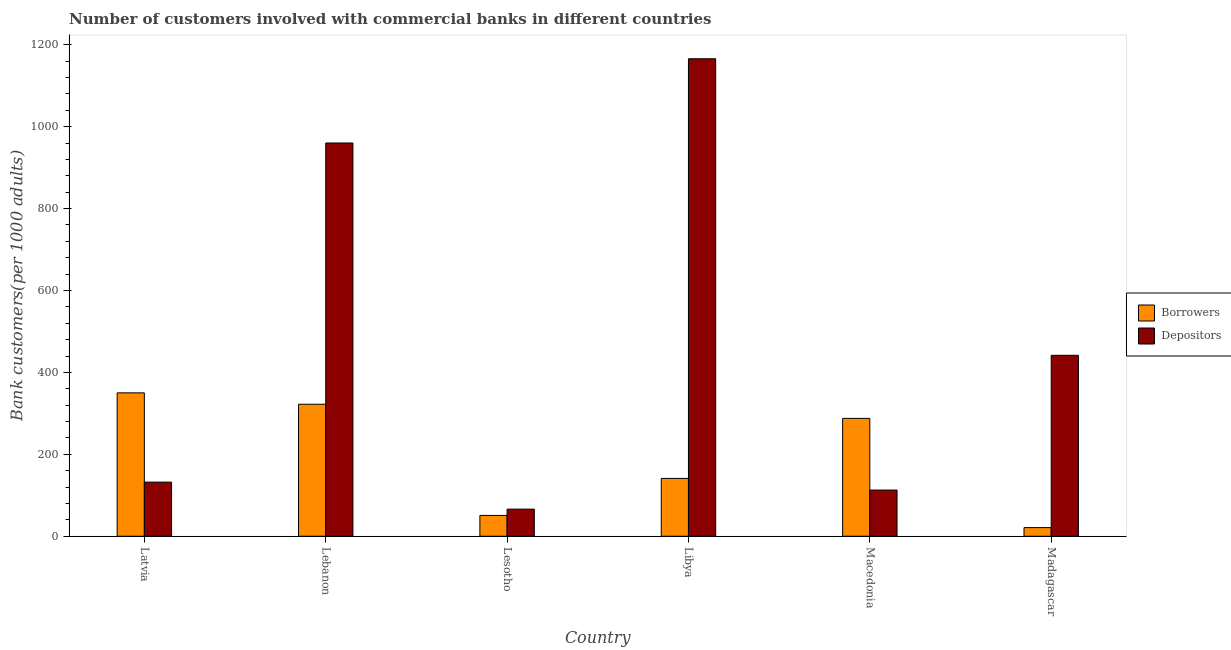How many different coloured bars are there?
Your response must be concise. 2. Are the number of bars per tick equal to the number of legend labels?
Provide a succinct answer. Yes. Are the number of bars on each tick of the X-axis equal?
Your answer should be very brief. Yes. How many bars are there on the 3rd tick from the left?
Your answer should be compact. 2. How many bars are there on the 5th tick from the right?
Offer a terse response. 2. What is the label of the 1st group of bars from the left?
Your response must be concise. Latvia. In how many cases, is the number of bars for a given country not equal to the number of legend labels?
Your answer should be compact. 0. What is the number of depositors in Macedonia?
Ensure brevity in your answer.  112.8. Across all countries, what is the maximum number of depositors?
Your response must be concise. 1165.93. Across all countries, what is the minimum number of borrowers?
Your answer should be compact. 21.11. In which country was the number of depositors maximum?
Keep it short and to the point. Libya. In which country was the number of depositors minimum?
Provide a short and direct response. Lesotho. What is the total number of borrowers in the graph?
Keep it short and to the point. 1173.48. What is the difference between the number of borrowers in Lesotho and that in Madagascar?
Offer a very short reply. 29.76. What is the difference between the number of borrowers in Macedonia and the number of depositors in Latvia?
Keep it short and to the point. 155.65. What is the average number of borrowers per country?
Offer a very short reply. 195.58. What is the difference between the number of borrowers and number of depositors in Madagascar?
Your answer should be compact. -420.71. What is the ratio of the number of depositors in Latvia to that in Lebanon?
Your answer should be very brief. 0.14. Is the number of borrowers in Latvia less than that in Libya?
Your answer should be compact. No. Is the difference between the number of borrowers in Lebanon and Lesotho greater than the difference between the number of depositors in Lebanon and Lesotho?
Your answer should be very brief. No. What is the difference between the highest and the second highest number of depositors?
Your response must be concise. 205.7. What is the difference between the highest and the lowest number of depositors?
Provide a short and direct response. 1099.7. In how many countries, is the number of borrowers greater than the average number of borrowers taken over all countries?
Offer a very short reply. 3. Is the sum of the number of borrowers in Libya and Madagascar greater than the maximum number of depositors across all countries?
Offer a very short reply. No. What does the 2nd bar from the left in Libya represents?
Ensure brevity in your answer.  Depositors. What does the 1st bar from the right in Latvia represents?
Give a very brief answer. Depositors. How many bars are there?
Make the answer very short. 12. Are all the bars in the graph horizontal?
Provide a short and direct response. No. Are the values on the major ticks of Y-axis written in scientific E-notation?
Offer a very short reply. No. Does the graph contain any zero values?
Give a very brief answer. No. Does the graph contain grids?
Your answer should be very brief. No. Where does the legend appear in the graph?
Provide a short and direct response. Center right. How many legend labels are there?
Give a very brief answer. 2. What is the title of the graph?
Make the answer very short. Number of customers involved with commercial banks in different countries. What is the label or title of the Y-axis?
Provide a succinct answer. Bank customers(per 1000 adults). What is the Bank customers(per 1000 adults) of Borrowers in Latvia?
Your response must be concise. 350.14. What is the Bank customers(per 1000 adults) of Depositors in Latvia?
Offer a terse response. 132.15. What is the Bank customers(per 1000 adults) of Borrowers in Lebanon?
Your answer should be compact. 322.32. What is the Bank customers(per 1000 adults) in Depositors in Lebanon?
Your answer should be compact. 960.23. What is the Bank customers(per 1000 adults) of Borrowers in Lesotho?
Provide a succinct answer. 50.87. What is the Bank customers(per 1000 adults) of Depositors in Lesotho?
Your answer should be very brief. 66.23. What is the Bank customers(per 1000 adults) in Borrowers in Libya?
Your response must be concise. 141.22. What is the Bank customers(per 1000 adults) in Depositors in Libya?
Your response must be concise. 1165.93. What is the Bank customers(per 1000 adults) of Borrowers in Macedonia?
Your answer should be very brief. 287.81. What is the Bank customers(per 1000 adults) in Depositors in Macedonia?
Ensure brevity in your answer.  112.8. What is the Bank customers(per 1000 adults) of Borrowers in Madagascar?
Make the answer very short. 21.11. What is the Bank customers(per 1000 adults) of Depositors in Madagascar?
Offer a terse response. 441.82. Across all countries, what is the maximum Bank customers(per 1000 adults) in Borrowers?
Give a very brief answer. 350.14. Across all countries, what is the maximum Bank customers(per 1000 adults) in Depositors?
Your answer should be compact. 1165.93. Across all countries, what is the minimum Bank customers(per 1000 adults) in Borrowers?
Keep it short and to the point. 21.11. Across all countries, what is the minimum Bank customers(per 1000 adults) of Depositors?
Your response must be concise. 66.23. What is the total Bank customers(per 1000 adults) in Borrowers in the graph?
Your answer should be compact. 1173.48. What is the total Bank customers(per 1000 adults) in Depositors in the graph?
Offer a terse response. 2879.17. What is the difference between the Bank customers(per 1000 adults) of Borrowers in Latvia and that in Lebanon?
Your response must be concise. 27.82. What is the difference between the Bank customers(per 1000 adults) of Depositors in Latvia and that in Lebanon?
Offer a terse response. -828.07. What is the difference between the Bank customers(per 1000 adults) in Borrowers in Latvia and that in Lesotho?
Offer a very short reply. 299.27. What is the difference between the Bank customers(per 1000 adults) of Depositors in Latvia and that in Lesotho?
Give a very brief answer. 65.92. What is the difference between the Bank customers(per 1000 adults) of Borrowers in Latvia and that in Libya?
Make the answer very short. 208.91. What is the difference between the Bank customers(per 1000 adults) in Depositors in Latvia and that in Libya?
Make the answer very short. -1033.78. What is the difference between the Bank customers(per 1000 adults) in Borrowers in Latvia and that in Macedonia?
Offer a very short reply. 62.33. What is the difference between the Bank customers(per 1000 adults) of Depositors in Latvia and that in Macedonia?
Provide a succinct answer. 19.35. What is the difference between the Bank customers(per 1000 adults) in Borrowers in Latvia and that in Madagascar?
Offer a very short reply. 329.02. What is the difference between the Bank customers(per 1000 adults) of Depositors in Latvia and that in Madagascar?
Give a very brief answer. -309.67. What is the difference between the Bank customers(per 1000 adults) of Borrowers in Lebanon and that in Lesotho?
Give a very brief answer. 271.45. What is the difference between the Bank customers(per 1000 adults) in Depositors in Lebanon and that in Lesotho?
Your answer should be very brief. 894. What is the difference between the Bank customers(per 1000 adults) in Borrowers in Lebanon and that in Libya?
Ensure brevity in your answer.  181.1. What is the difference between the Bank customers(per 1000 adults) in Depositors in Lebanon and that in Libya?
Keep it short and to the point. -205.7. What is the difference between the Bank customers(per 1000 adults) of Borrowers in Lebanon and that in Macedonia?
Provide a short and direct response. 34.51. What is the difference between the Bank customers(per 1000 adults) of Depositors in Lebanon and that in Macedonia?
Give a very brief answer. 847.43. What is the difference between the Bank customers(per 1000 adults) in Borrowers in Lebanon and that in Madagascar?
Give a very brief answer. 301.21. What is the difference between the Bank customers(per 1000 adults) in Depositors in Lebanon and that in Madagascar?
Keep it short and to the point. 518.41. What is the difference between the Bank customers(per 1000 adults) of Borrowers in Lesotho and that in Libya?
Your answer should be compact. -90.35. What is the difference between the Bank customers(per 1000 adults) in Depositors in Lesotho and that in Libya?
Provide a short and direct response. -1099.7. What is the difference between the Bank customers(per 1000 adults) in Borrowers in Lesotho and that in Macedonia?
Keep it short and to the point. -236.94. What is the difference between the Bank customers(per 1000 adults) of Depositors in Lesotho and that in Macedonia?
Provide a short and direct response. -46.57. What is the difference between the Bank customers(per 1000 adults) of Borrowers in Lesotho and that in Madagascar?
Your answer should be very brief. 29.76. What is the difference between the Bank customers(per 1000 adults) of Depositors in Lesotho and that in Madagascar?
Keep it short and to the point. -375.59. What is the difference between the Bank customers(per 1000 adults) in Borrowers in Libya and that in Macedonia?
Provide a short and direct response. -146.58. What is the difference between the Bank customers(per 1000 adults) in Depositors in Libya and that in Macedonia?
Your response must be concise. 1053.13. What is the difference between the Bank customers(per 1000 adults) of Borrowers in Libya and that in Madagascar?
Your answer should be very brief. 120.11. What is the difference between the Bank customers(per 1000 adults) in Depositors in Libya and that in Madagascar?
Give a very brief answer. 724.11. What is the difference between the Bank customers(per 1000 adults) in Borrowers in Macedonia and that in Madagascar?
Offer a very short reply. 266.69. What is the difference between the Bank customers(per 1000 adults) of Depositors in Macedonia and that in Madagascar?
Your response must be concise. -329.02. What is the difference between the Bank customers(per 1000 adults) of Borrowers in Latvia and the Bank customers(per 1000 adults) of Depositors in Lebanon?
Make the answer very short. -610.09. What is the difference between the Bank customers(per 1000 adults) in Borrowers in Latvia and the Bank customers(per 1000 adults) in Depositors in Lesotho?
Your answer should be very brief. 283.91. What is the difference between the Bank customers(per 1000 adults) of Borrowers in Latvia and the Bank customers(per 1000 adults) of Depositors in Libya?
Give a very brief answer. -815.79. What is the difference between the Bank customers(per 1000 adults) of Borrowers in Latvia and the Bank customers(per 1000 adults) of Depositors in Macedonia?
Give a very brief answer. 237.34. What is the difference between the Bank customers(per 1000 adults) of Borrowers in Latvia and the Bank customers(per 1000 adults) of Depositors in Madagascar?
Offer a very short reply. -91.68. What is the difference between the Bank customers(per 1000 adults) of Borrowers in Lebanon and the Bank customers(per 1000 adults) of Depositors in Lesotho?
Ensure brevity in your answer.  256.09. What is the difference between the Bank customers(per 1000 adults) of Borrowers in Lebanon and the Bank customers(per 1000 adults) of Depositors in Libya?
Your response must be concise. -843.61. What is the difference between the Bank customers(per 1000 adults) of Borrowers in Lebanon and the Bank customers(per 1000 adults) of Depositors in Macedonia?
Your answer should be very brief. 209.52. What is the difference between the Bank customers(per 1000 adults) in Borrowers in Lebanon and the Bank customers(per 1000 adults) in Depositors in Madagascar?
Offer a terse response. -119.5. What is the difference between the Bank customers(per 1000 adults) of Borrowers in Lesotho and the Bank customers(per 1000 adults) of Depositors in Libya?
Provide a short and direct response. -1115.06. What is the difference between the Bank customers(per 1000 adults) of Borrowers in Lesotho and the Bank customers(per 1000 adults) of Depositors in Macedonia?
Offer a very short reply. -61.93. What is the difference between the Bank customers(per 1000 adults) in Borrowers in Lesotho and the Bank customers(per 1000 adults) in Depositors in Madagascar?
Provide a short and direct response. -390.95. What is the difference between the Bank customers(per 1000 adults) in Borrowers in Libya and the Bank customers(per 1000 adults) in Depositors in Macedonia?
Offer a very short reply. 28.42. What is the difference between the Bank customers(per 1000 adults) in Borrowers in Libya and the Bank customers(per 1000 adults) in Depositors in Madagascar?
Give a very brief answer. -300.6. What is the difference between the Bank customers(per 1000 adults) of Borrowers in Macedonia and the Bank customers(per 1000 adults) of Depositors in Madagascar?
Provide a succinct answer. -154.01. What is the average Bank customers(per 1000 adults) in Borrowers per country?
Your response must be concise. 195.58. What is the average Bank customers(per 1000 adults) of Depositors per country?
Offer a terse response. 479.86. What is the difference between the Bank customers(per 1000 adults) of Borrowers and Bank customers(per 1000 adults) of Depositors in Latvia?
Offer a very short reply. 217.98. What is the difference between the Bank customers(per 1000 adults) of Borrowers and Bank customers(per 1000 adults) of Depositors in Lebanon?
Ensure brevity in your answer.  -637.91. What is the difference between the Bank customers(per 1000 adults) of Borrowers and Bank customers(per 1000 adults) of Depositors in Lesotho?
Keep it short and to the point. -15.36. What is the difference between the Bank customers(per 1000 adults) in Borrowers and Bank customers(per 1000 adults) in Depositors in Libya?
Your answer should be very brief. -1024.71. What is the difference between the Bank customers(per 1000 adults) of Borrowers and Bank customers(per 1000 adults) of Depositors in Macedonia?
Offer a very short reply. 175.01. What is the difference between the Bank customers(per 1000 adults) of Borrowers and Bank customers(per 1000 adults) of Depositors in Madagascar?
Provide a succinct answer. -420.71. What is the ratio of the Bank customers(per 1000 adults) of Borrowers in Latvia to that in Lebanon?
Provide a short and direct response. 1.09. What is the ratio of the Bank customers(per 1000 adults) in Depositors in Latvia to that in Lebanon?
Your response must be concise. 0.14. What is the ratio of the Bank customers(per 1000 adults) of Borrowers in Latvia to that in Lesotho?
Provide a short and direct response. 6.88. What is the ratio of the Bank customers(per 1000 adults) in Depositors in Latvia to that in Lesotho?
Give a very brief answer. 2. What is the ratio of the Bank customers(per 1000 adults) in Borrowers in Latvia to that in Libya?
Offer a very short reply. 2.48. What is the ratio of the Bank customers(per 1000 adults) in Depositors in Latvia to that in Libya?
Provide a succinct answer. 0.11. What is the ratio of the Bank customers(per 1000 adults) of Borrowers in Latvia to that in Macedonia?
Offer a very short reply. 1.22. What is the ratio of the Bank customers(per 1000 adults) in Depositors in Latvia to that in Macedonia?
Give a very brief answer. 1.17. What is the ratio of the Bank customers(per 1000 adults) of Borrowers in Latvia to that in Madagascar?
Ensure brevity in your answer.  16.58. What is the ratio of the Bank customers(per 1000 adults) of Depositors in Latvia to that in Madagascar?
Ensure brevity in your answer.  0.3. What is the ratio of the Bank customers(per 1000 adults) of Borrowers in Lebanon to that in Lesotho?
Provide a succinct answer. 6.34. What is the ratio of the Bank customers(per 1000 adults) of Depositors in Lebanon to that in Lesotho?
Make the answer very short. 14.5. What is the ratio of the Bank customers(per 1000 adults) in Borrowers in Lebanon to that in Libya?
Provide a short and direct response. 2.28. What is the ratio of the Bank customers(per 1000 adults) of Depositors in Lebanon to that in Libya?
Give a very brief answer. 0.82. What is the ratio of the Bank customers(per 1000 adults) of Borrowers in Lebanon to that in Macedonia?
Ensure brevity in your answer.  1.12. What is the ratio of the Bank customers(per 1000 adults) in Depositors in Lebanon to that in Macedonia?
Your answer should be compact. 8.51. What is the ratio of the Bank customers(per 1000 adults) in Borrowers in Lebanon to that in Madagascar?
Your response must be concise. 15.27. What is the ratio of the Bank customers(per 1000 adults) of Depositors in Lebanon to that in Madagascar?
Keep it short and to the point. 2.17. What is the ratio of the Bank customers(per 1000 adults) of Borrowers in Lesotho to that in Libya?
Make the answer very short. 0.36. What is the ratio of the Bank customers(per 1000 adults) of Depositors in Lesotho to that in Libya?
Your response must be concise. 0.06. What is the ratio of the Bank customers(per 1000 adults) in Borrowers in Lesotho to that in Macedonia?
Your response must be concise. 0.18. What is the ratio of the Bank customers(per 1000 adults) in Depositors in Lesotho to that in Macedonia?
Your answer should be compact. 0.59. What is the ratio of the Bank customers(per 1000 adults) in Borrowers in Lesotho to that in Madagascar?
Ensure brevity in your answer.  2.41. What is the ratio of the Bank customers(per 1000 adults) in Depositors in Lesotho to that in Madagascar?
Offer a terse response. 0.15. What is the ratio of the Bank customers(per 1000 adults) of Borrowers in Libya to that in Macedonia?
Make the answer very short. 0.49. What is the ratio of the Bank customers(per 1000 adults) of Depositors in Libya to that in Macedonia?
Make the answer very short. 10.34. What is the ratio of the Bank customers(per 1000 adults) of Borrowers in Libya to that in Madagascar?
Your answer should be compact. 6.69. What is the ratio of the Bank customers(per 1000 adults) in Depositors in Libya to that in Madagascar?
Offer a very short reply. 2.64. What is the ratio of the Bank customers(per 1000 adults) of Borrowers in Macedonia to that in Madagascar?
Offer a very short reply. 13.63. What is the ratio of the Bank customers(per 1000 adults) in Depositors in Macedonia to that in Madagascar?
Ensure brevity in your answer.  0.26. What is the difference between the highest and the second highest Bank customers(per 1000 adults) of Borrowers?
Provide a succinct answer. 27.82. What is the difference between the highest and the second highest Bank customers(per 1000 adults) of Depositors?
Provide a short and direct response. 205.7. What is the difference between the highest and the lowest Bank customers(per 1000 adults) of Borrowers?
Ensure brevity in your answer.  329.02. What is the difference between the highest and the lowest Bank customers(per 1000 adults) of Depositors?
Provide a short and direct response. 1099.7. 